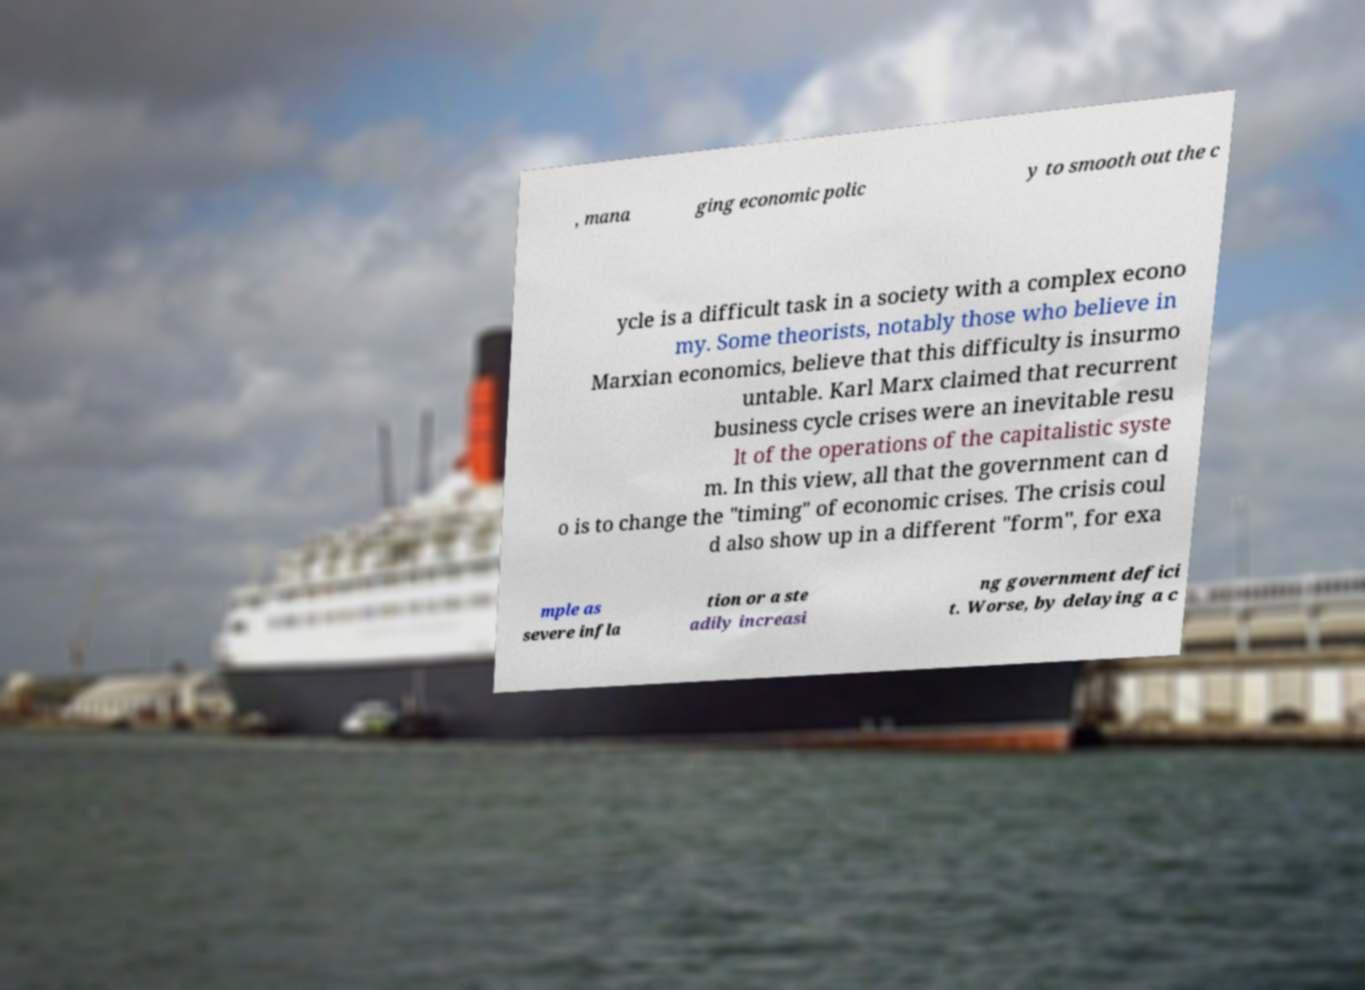Could you assist in decoding the text presented in this image and type it out clearly? , mana ging economic polic y to smooth out the c ycle is a difficult task in a society with a complex econo my. Some theorists, notably those who believe in Marxian economics, believe that this difficulty is insurmo untable. Karl Marx claimed that recurrent business cycle crises were an inevitable resu lt of the operations of the capitalistic syste m. In this view, all that the government can d o is to change the "timing" of economic crises. The crisis coul d also show up in a different "form", for exa mple as severe infla tion or a ste adily increasi ng government defici t. Worse, by delaying a c 